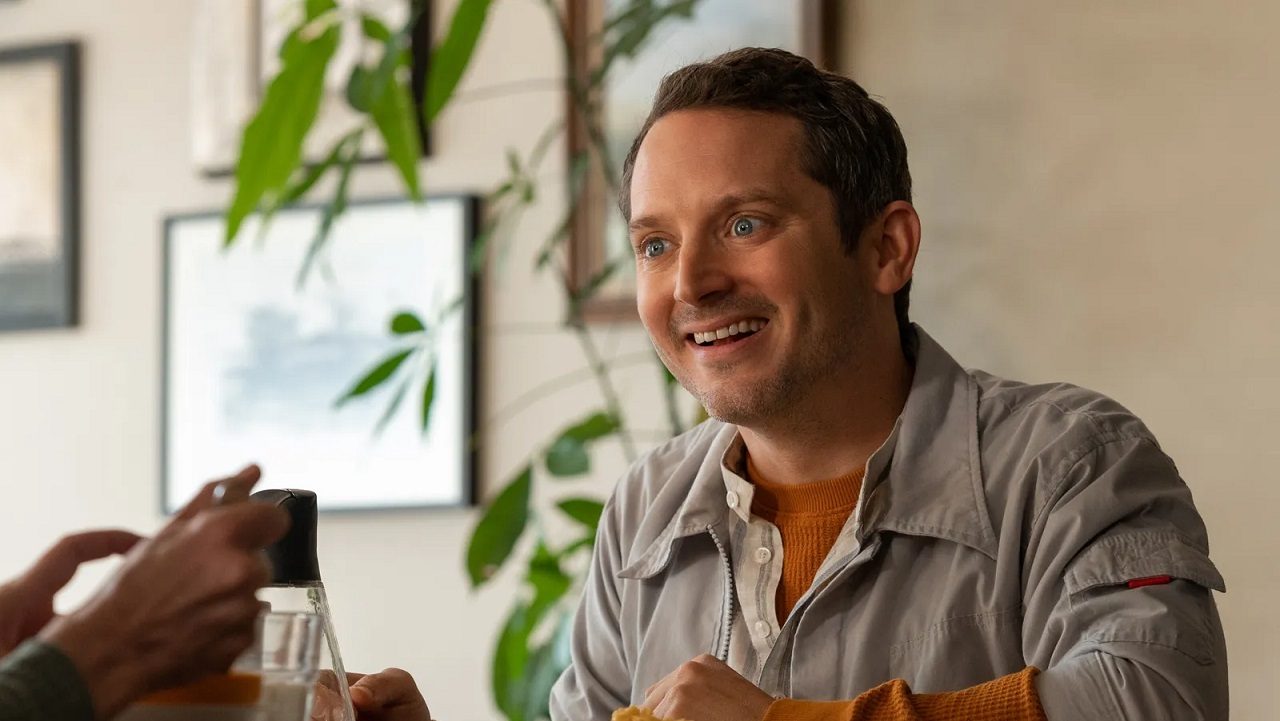Describe the emotions conveyed by the person in the image. The person in the image conveys a sense of happiness and engagement. His broad smile and wide eyes suggest he is genuinely enjoying the moment, perhaps sharing a laugh or an interesting conversation with someone off-camera. His relaxed posture and the casual setting further emphasize a feeling of comfort and contentment. 